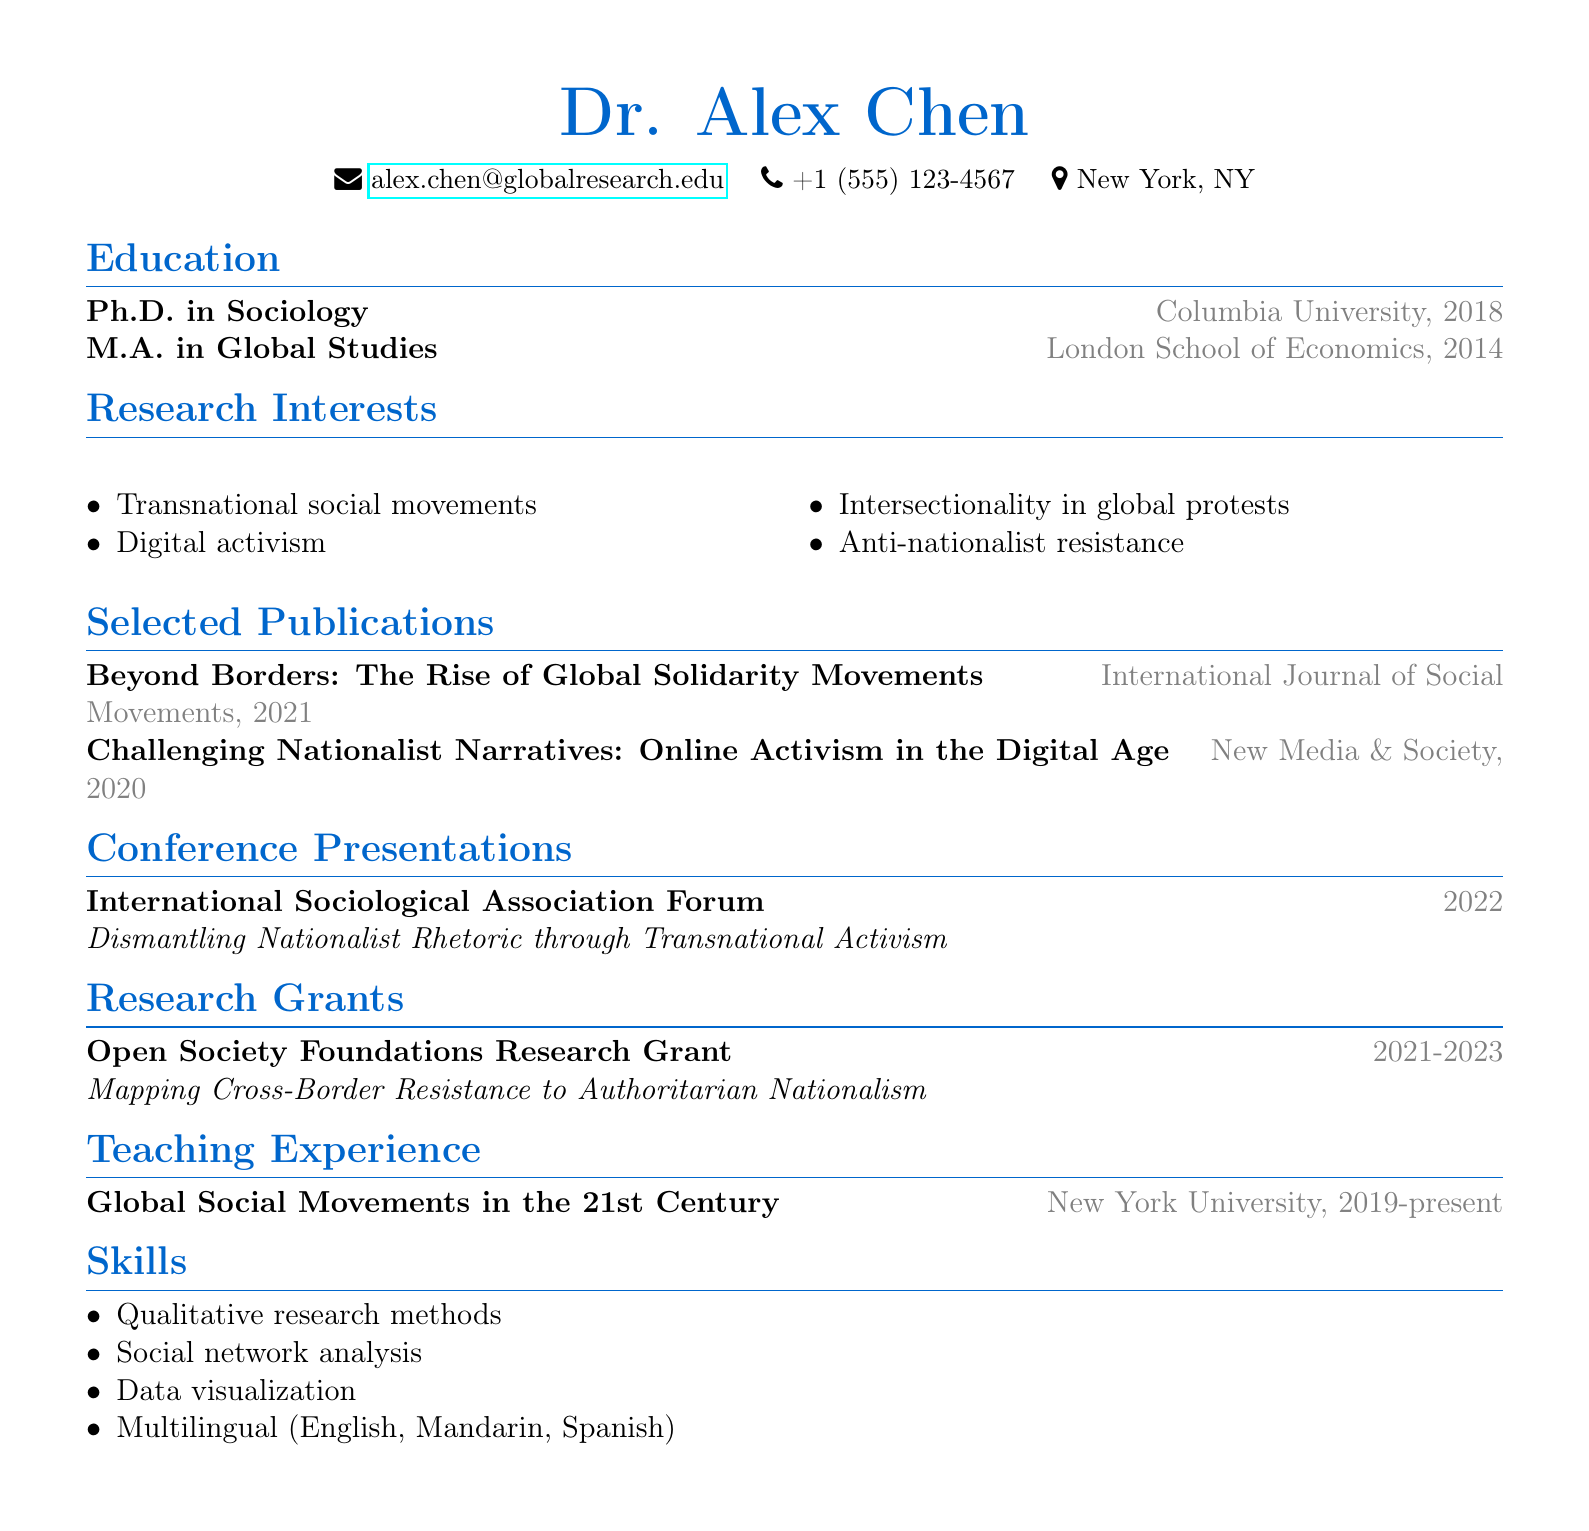what is the name of the academic? The name of the academic is provided in the first section of the document.
Answer: Dr. Alex Chen what year did Dr. Alex Chen obtain their Ph.D.? The year is indicated in the education section near the degree mention.
Answer: 2018 which institution awarded Dr. Alex Chen a Master's degree? The institution is listed in the education section for the M.A. degree.
Answer: London School of Economics what is one of Dr. Alex Chen's research interests? Research interests are listed in a dedicated section, highlighting specific areas of focus.
Answer: Anti-nationalist resistance what type of grant has Dr. Alex Chen received? The grant type is specified in the research grants section, detailing the organization's support.
Answer: Open Society Foundations Research Grant how long is Dr. Alex Chen's teaching experience at New York University? The duration is mentioned in the teaching experience section, covering start date to the present.
Answer: Since 2019 in which journal was the publication "Challenging Nationalist Narratives" featured? The journal title is mentioned alongside the publication title in the selected publications section.
Answer: New Media & Society name one qualitative research skill listed in the CV. The skills section provides a variety of methods and capabilities.
Answer: Qualitative research methods what was the focus of Dr. Alex Chen's conference presentation in 2022? The focus is described in the conference presentations section, outlining the subject matter of the talk.
Answer: Dismantling Nationalist Rhetoric through Transnational Activism 